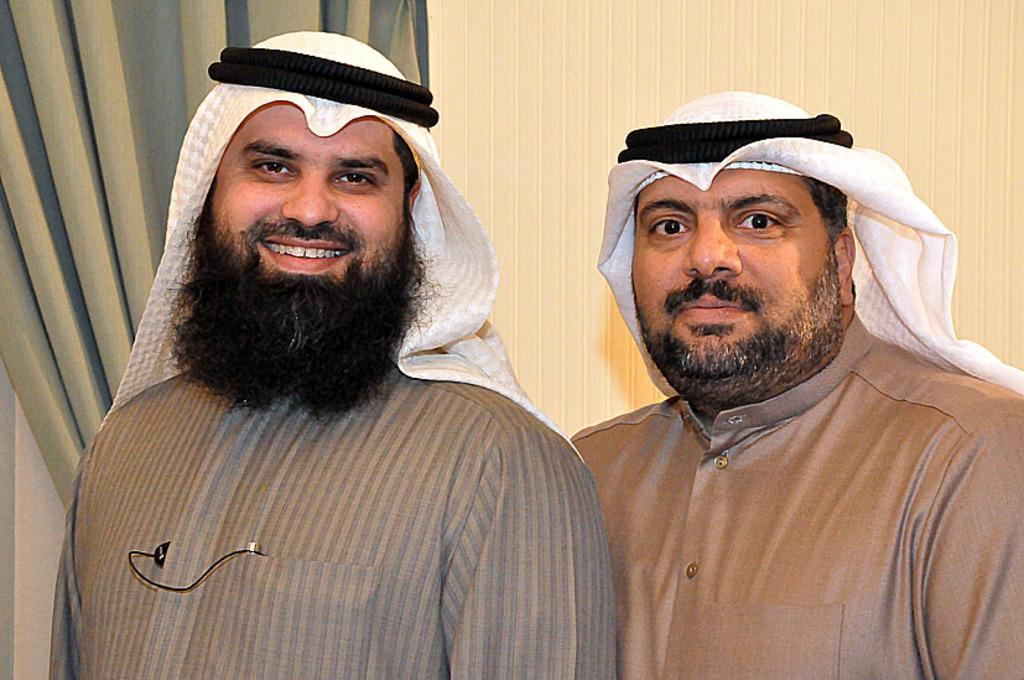How many people are in the image? There are two men in the image. What are the men wearing on their heads? The men are wearing black, round-shaped objects on their heads. What else are the men wearing? The men are wearing white scarves. What is the facial expression of the men in the image? The men are smiling. What can be seen in the background of the image? There is a wall and curtains visible in the background of the image. What type of basin is being used for division in the image? There is no basin or division present in the image; it features two men wearing black, round-shaped objects on their heads and white scarves, while smiling. How does the wind blow in the image? There is no wind or blowing action depicted in the image. 